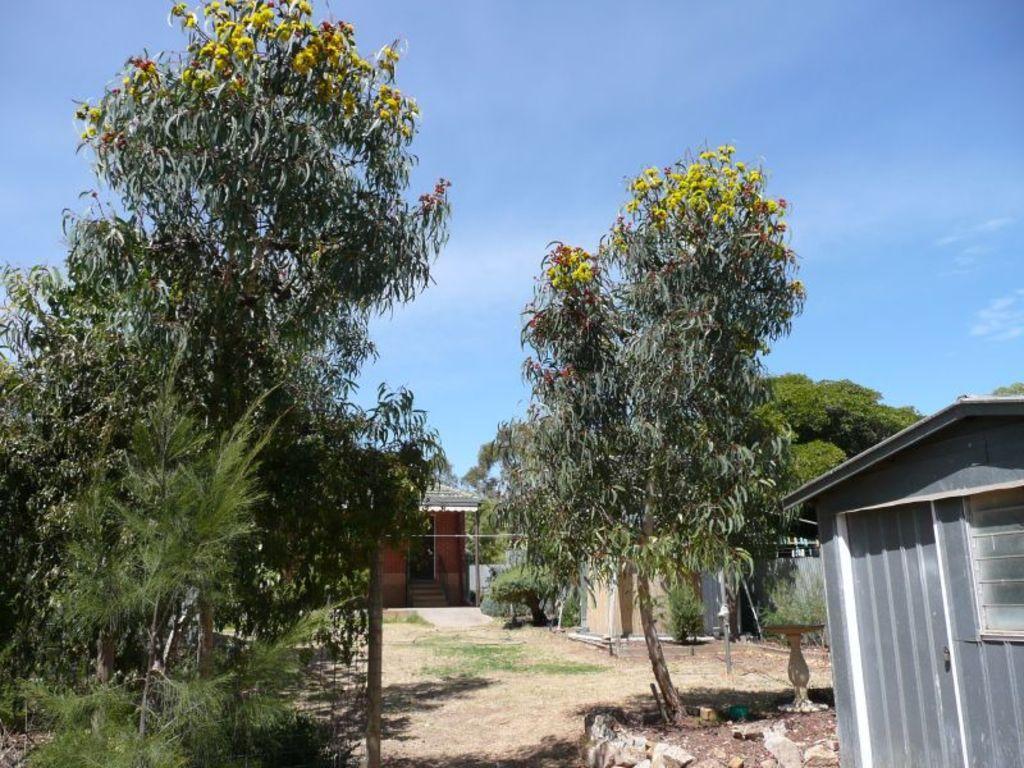How would you summarize this image in a sentence or two? On the right side of the image there is a room with roof, wall, door and a window. There are many trees in the image. On the ground there are stones. Behind the trees there are rooms with roofs, walls, doors and also there are steps. In the background there is sky. 